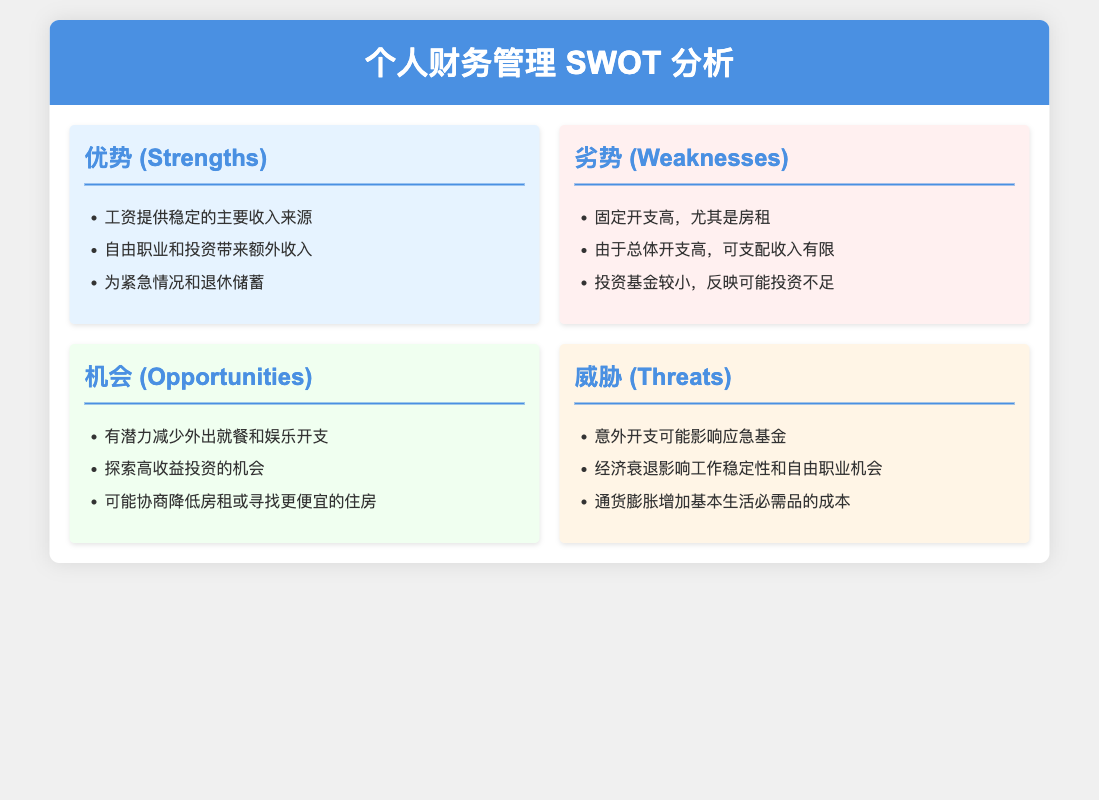What are the strengths listed in the SWOT analysis? The strengths are found in the section titled "优势 (Strengths)," which outlines key positive aspects.
Answer: 工资提供稳定的主要收入来源; 自由职业和投资带来额外收入; 为紧急情况和退休储蓄 What is one of the weaknesses mentioned? The weaknesses section "劣势 (Weaknesses)" points out specific challenges faced.
Answer: 固定开支高，尤其是房租 What opportunities are highlighted in the analysis? The opportunities are detailed in the "机会 (Opportunities)" section, which talks about potential areas for improvement.
Answer: 有潜力减少外出就餐和娱乐开支 What threat involves unexpected costs? The threats in the "威胁 (Threats)" section discuss potential negative impacts, including financial challenges.
Answer: 意外开支可能影响应急基金 How many strengths are listed? The strengths section lists specific advantages, and counting them provides the answer.
Answer: 3 What type of document is this? The contents and sections indicate that it's a SWOT analysis, focusing on personal finance management.
Answer: SWOT分析 Which category mentions the impact of inflation? The category discussing economic challenges affects budgeting and expenses, noted in the threats section.
Answer: 威胁 (Threats) What is one potential way to lower expenses mentioned in opportunities? The opportunities section suggests actions to improve financial management, including specific cost-saving measures.
Answer: 探索高收益投资的机会 